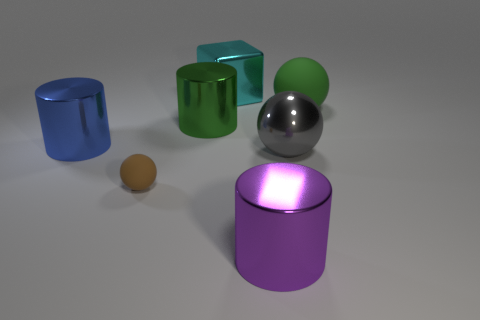There is a metal object that is the same color as the big rubber sphere; what shape is it?
Give a very brief answer. Cylinder. Are any large blue rubber things visible?
Provide a short and direct response. No. What color is the cube that is the same material as the large purple cylinder?
Your answer should be very brief. Cyan. There is a big block behind the big cylinder in front of the thing on the left side of the small sphere; what color is it?
Give a very brief answer. Cyan. There is a cyan thing; does it have the same size as the ball left of the gray metal sphere?
Offer a very short reply. No. What number of things are either shiny cylinders right of the cyan metal block or metal things right of the metallic block?
Your answer should be compact. 2. There is a purple thing that is the same size as the shiny ball; what shape is it?
Ensure brevity in your answer.  Cylinder. There is a big green object to the left of the metal cylinder that is in front of the big metallic cylinder that is left of the small brown rubber thing; what shape is it?
Make the answer very short. Cylinder. Are there the same number of large cyan objects on the left side of the big blue object and big cyan shiny spheres?
Your response must be concise. Yes. Does the green matte sphere have the same size as the brown ball?
Your response must be concise. No. 